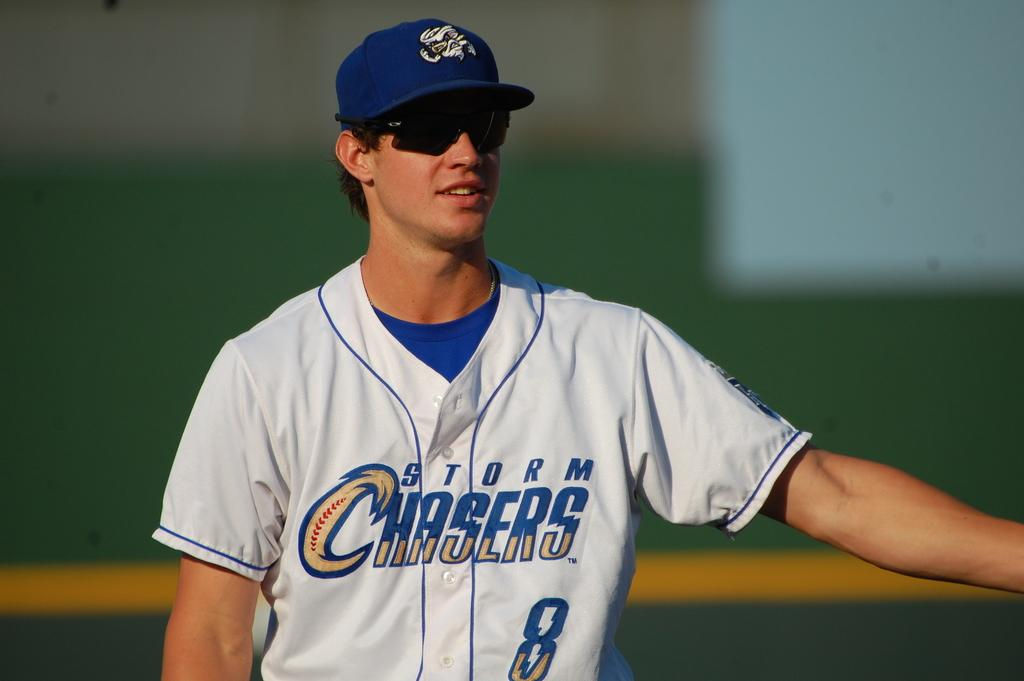<image>
Give a short and clear explanation of the subsequent image. Storm Chasers #8 baseball player with his arm out and wearing sunglasses. 